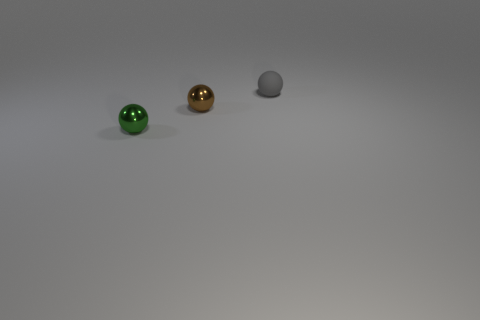Add 3 brown blocks. How many objects exist? 6 Subtract all small metallic objects. Subtract all gray objects. How many objects are left? 0 Add 1 gray rubber things. How many gray rubber things are left? 2 Add 3 small gray matte things. How many small gray matte things exist? 4 Subtract 0 purple blocks. How many objects are left? 3 